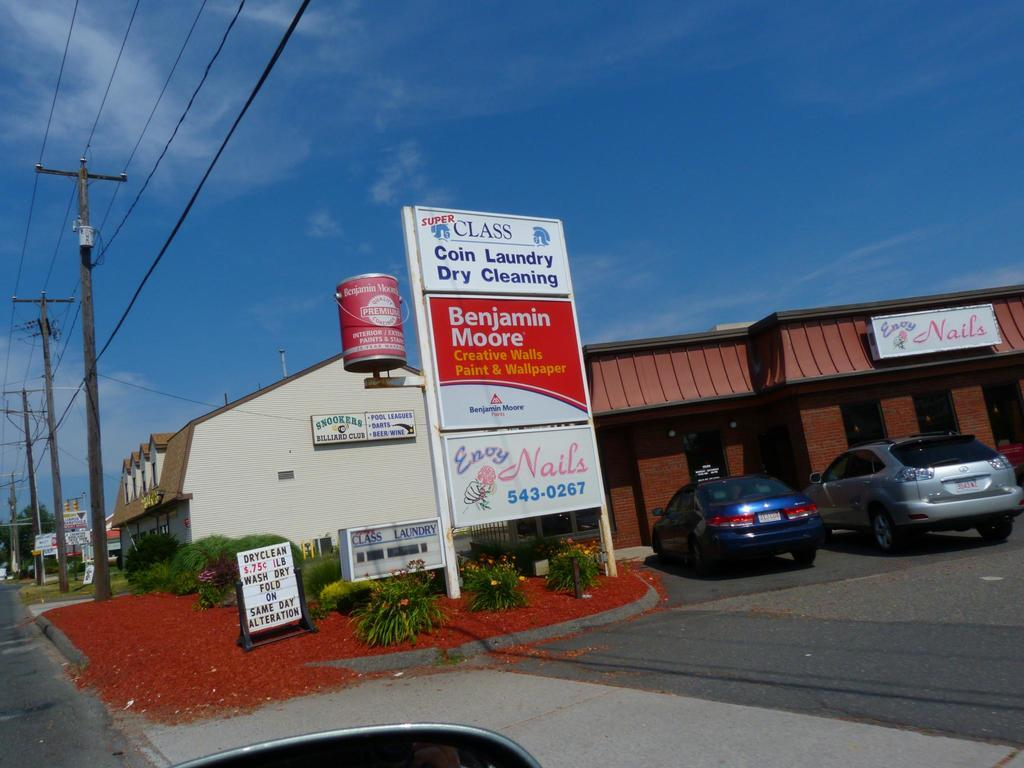<image>
Offer a succinct explanation of the picture presented. You can get your dry cleaning done at the same time as your nails at this strip mall. 